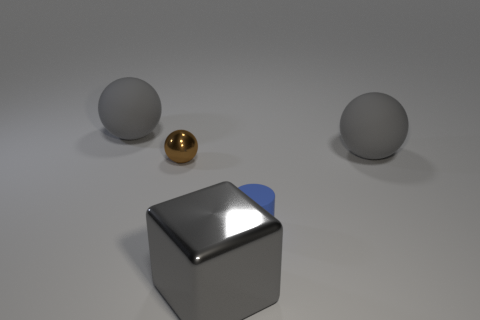Subtract all gray spheres. How many were subtracted if there are1gray spheres left? 1 Subtract all large spheres. How many spheres are left? 1 Add 2 tiny metallic objects. How many objects exist? 7 Subtract all brown spheres. How many spheres are left? 2 Subtract all cylinders. How many objects are left? 4 Subtract all blue balls. How many cyan cylinders are left? 0 Subtract all matte spheres. Subtract all blue rubber objects. How many objects are left? 2 Add 3 tiny brown metal balls. How many tiny brown metal balls are left? 4 Add 1 large green shiny blocks. How many large green shiny blocks exist? 1 Subtract 0 red balls. How many objects are left? 5 